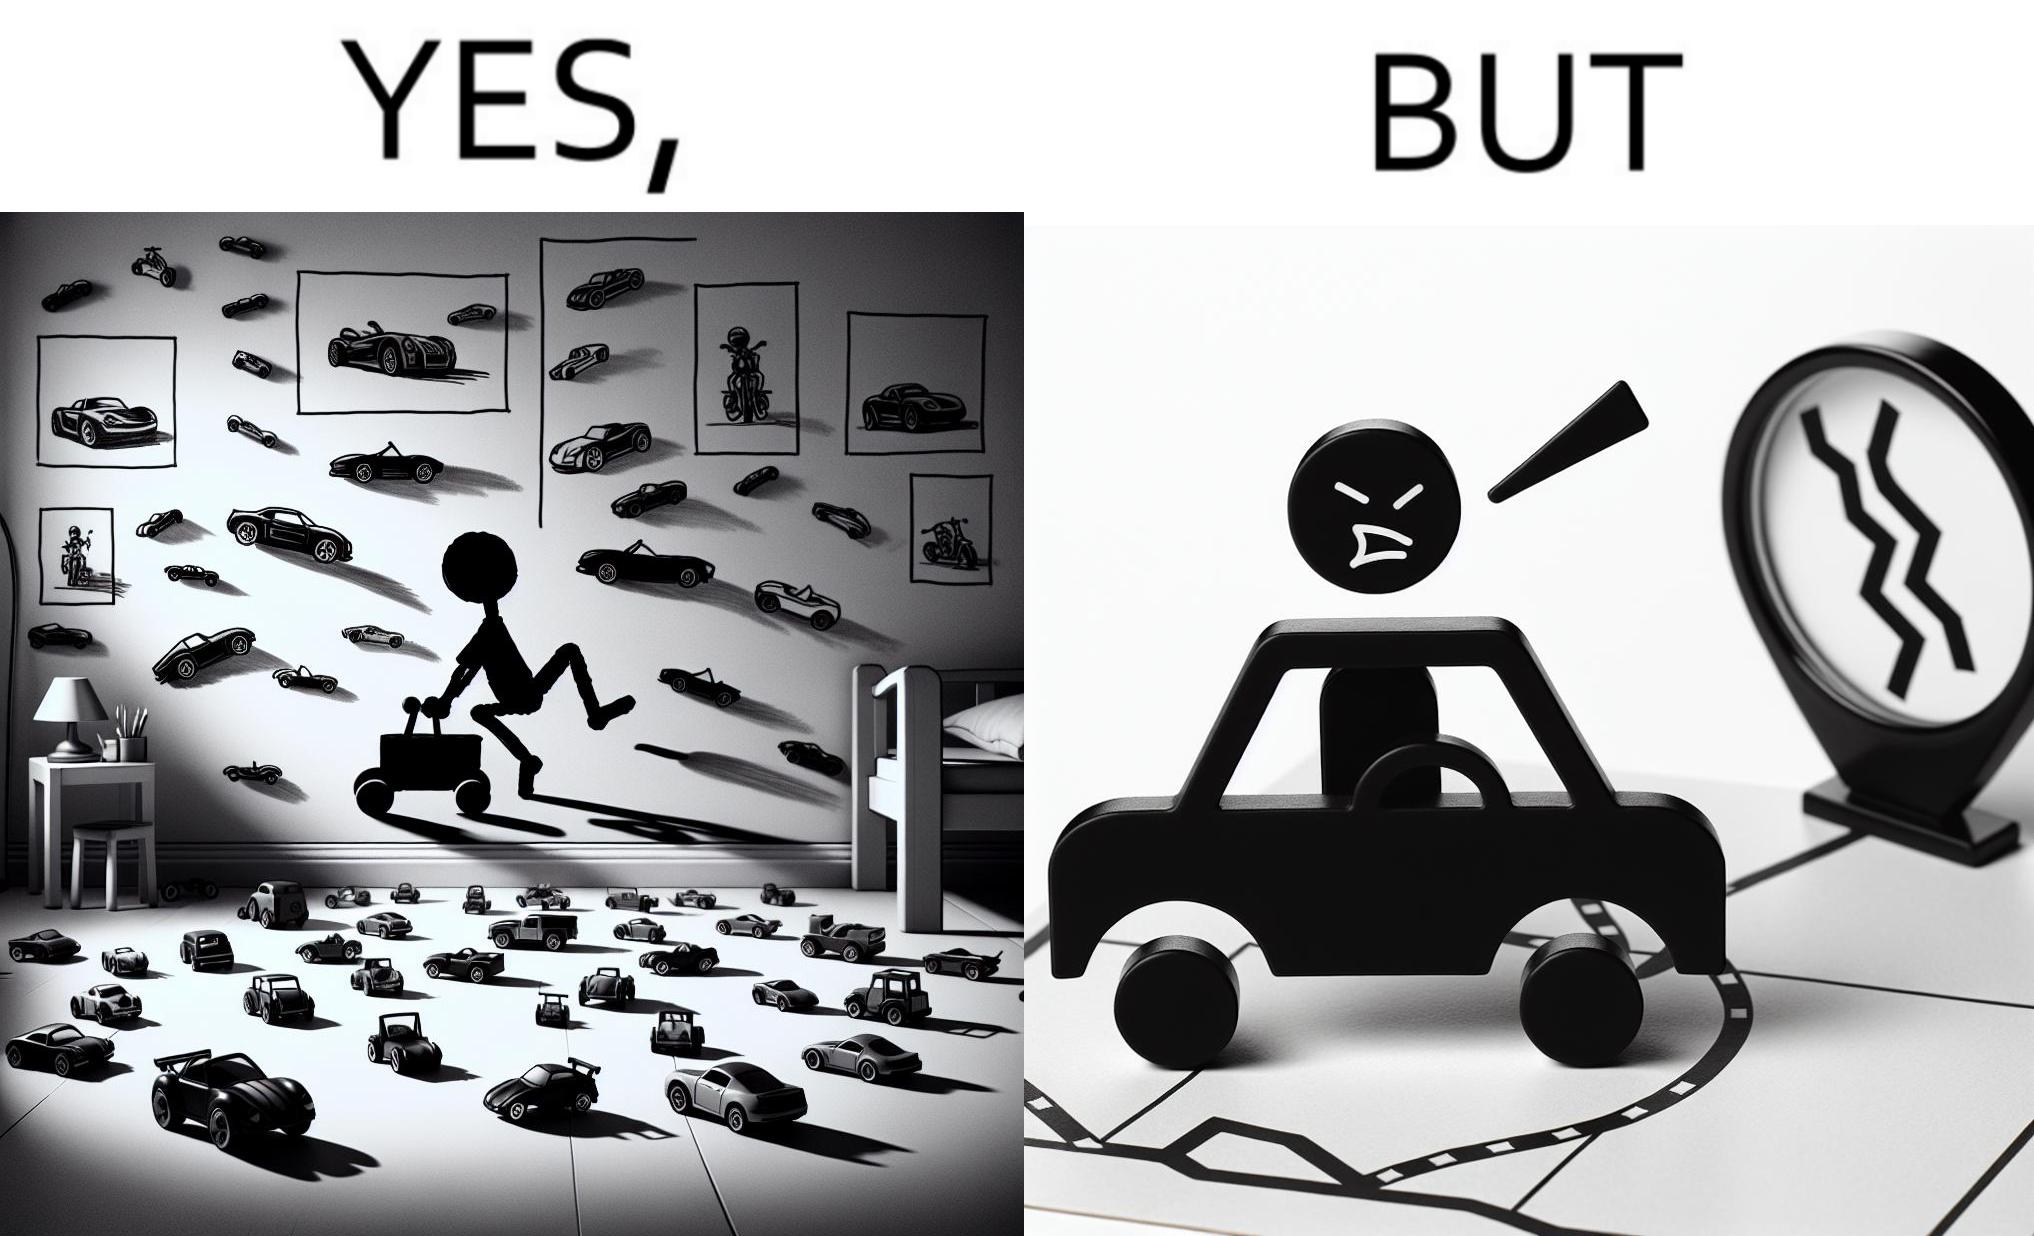What does this image depict? The image is funny beaucse while the person as a child enjoyed being around cars, had various small toy cars and even rode a bigger toy car, as as grown up he does not enjoy being in a car during a traffic jam while he is driving . 